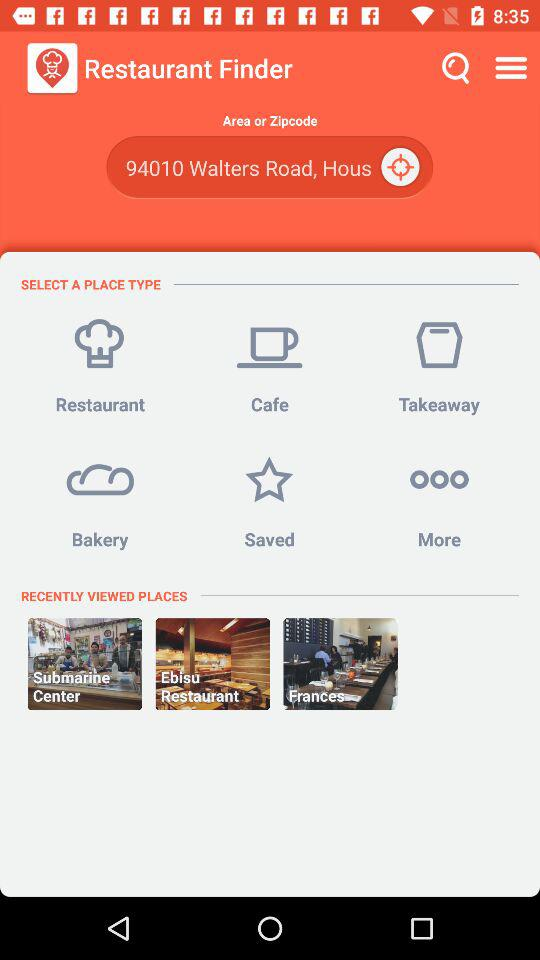What are the recently viewed places? The recently viewed places are "Submarine Center", "Ebisu Restaurant" and "Frances". 